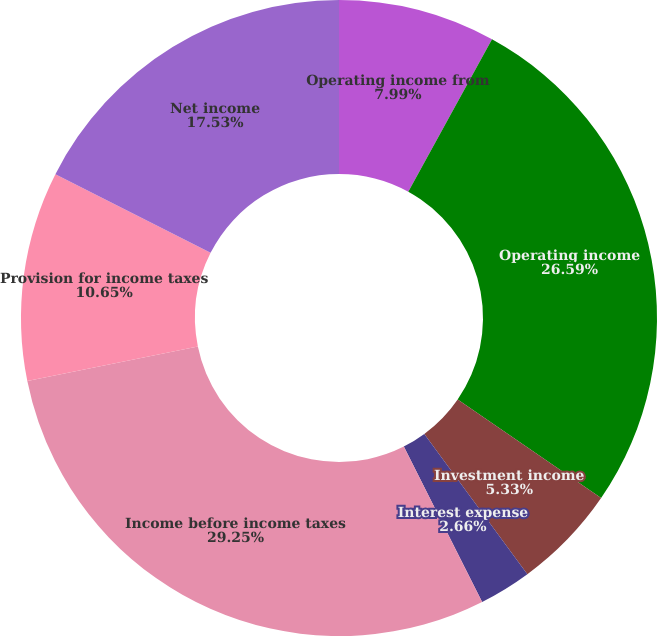Convert chart to OTSL. <chart><loc_0><loc_0><loc_500><loc_500><pie_chart><fcel>Operating income from<fcel>Operating income<fcel>Investment income<fcel>Interest expense<fcel>Income before income taxes<fcel>Provision for income taxes<fcel>Net income<fcel>Diluted earnings per share<nl><fcel>7.99%<fcel>26.59%<fcel>5.33%<fcel>2.66%<fcel>29.25%<fcel>10.65%<fcel>17.53%<fcel>0.0%<nl></chart> 